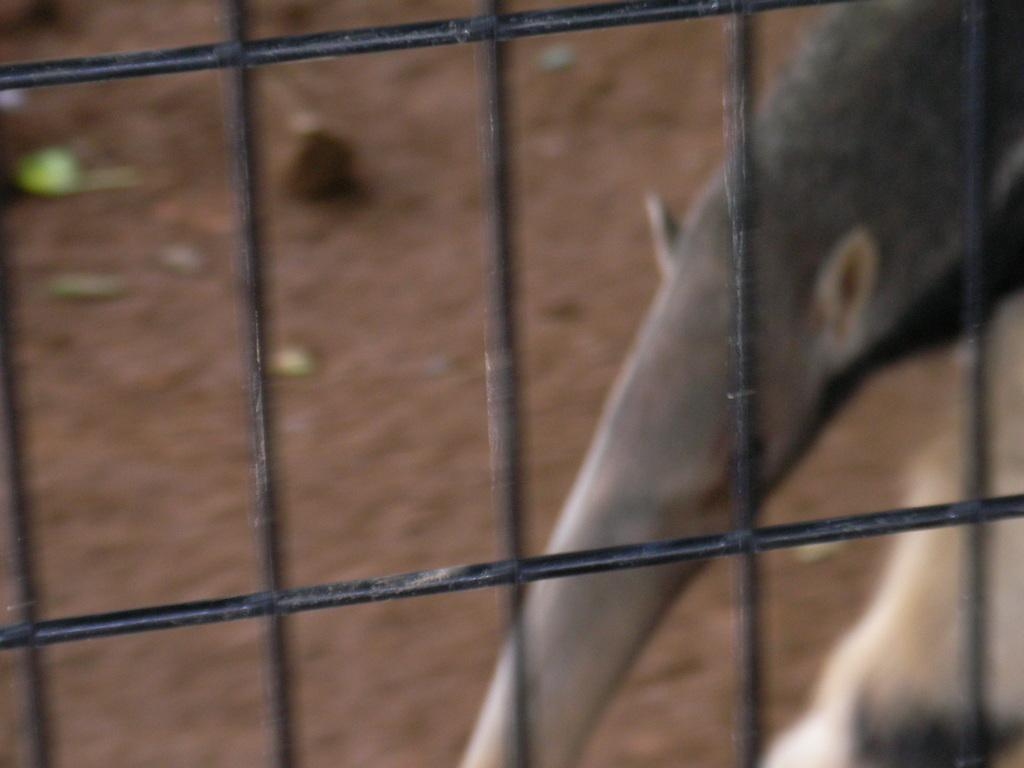What type of barrier can be seen in the image? There is a wire fence in the image. Can you describe the animal visible in the background of the image? Unfortunately, the facts provided do not give enough information to describe the animal. What is the primary purpose of the wire fence in the image? The primary purpose of the wire fence cannot be determined from the provided facts. What type of instrument is the animal playing in the image? There is no instrument present in the image, and the animal is not shown playing anything. 